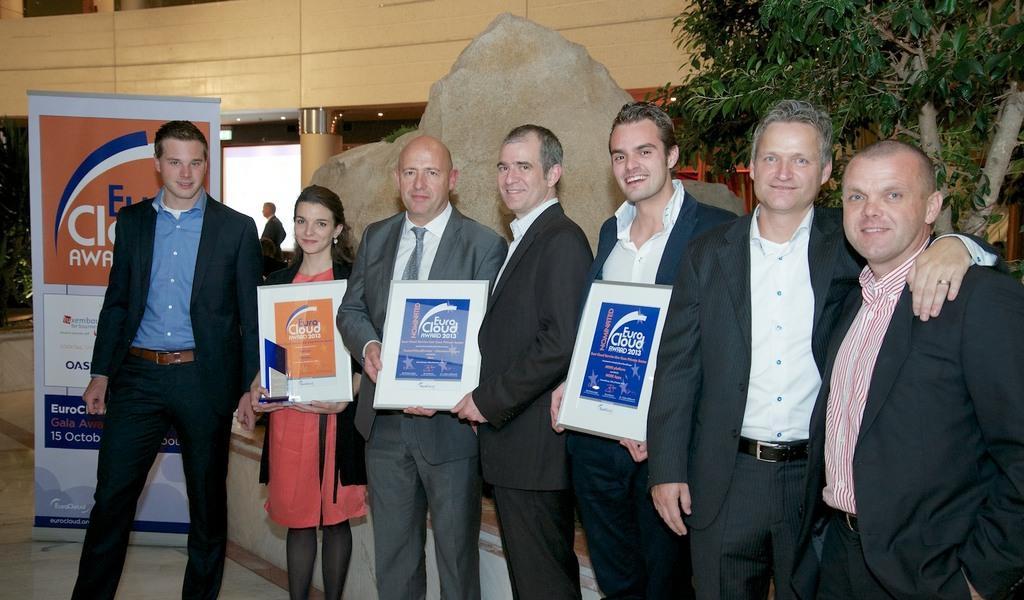Could you give a brief overview of what you see in this image? On the left side a man is standing, he wore a coat, trouser. Behind him there is a banner, beside him a beautiful girl is standing and other men are also standing at here. On the right side there is a tree. 